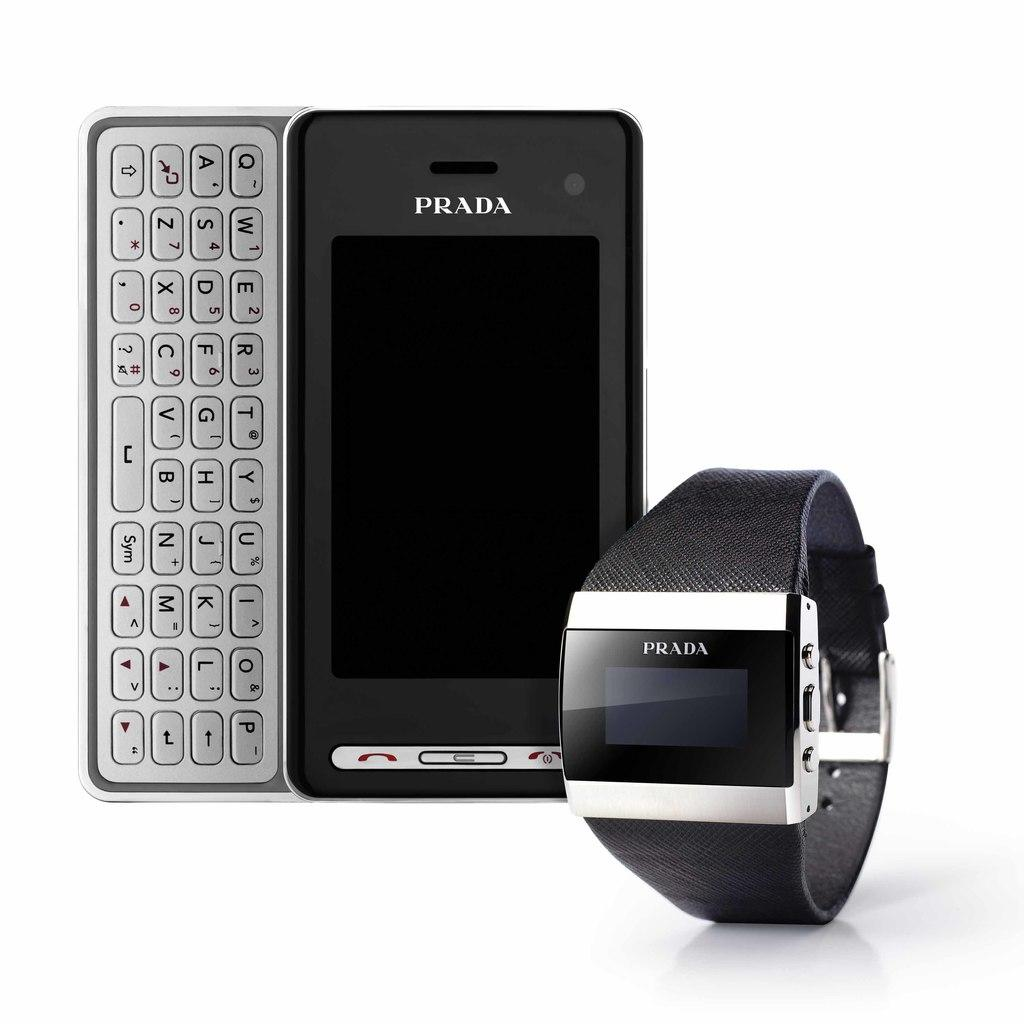<image>
Summarize the visual content of the image. Two devices manufactured by Prada including one to wear on a wrist. 